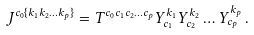<formula> <loc_0><loc_0><loc_500><loc_500>J ^ { c _ { 0 } \{ k _ { 1 } k _ { 2 } \dots k _ { p } \} } = T ^ { c _ { 0 } c _ { 1 } c _ { 2 } \dots c _ { p } } Y _ { c _ { 1 } } ^ { k _ { 1 } } Y _ { c _ { 2 } } ^ { k _ { 2 } } \dots Y _ { c _ { p } } ^ { k _ { p } } \, .</formula> 